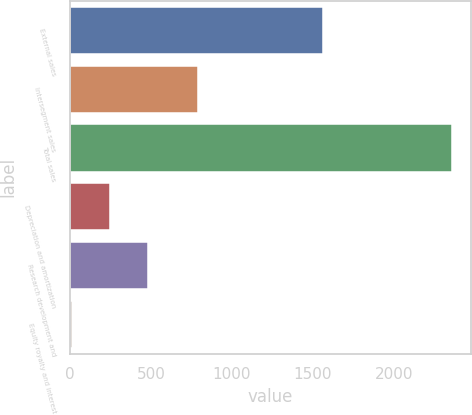Convert chart. <chart><loc_0><loc_0><loc_500><loc_500><bar_chart><fcel>External sales<fcel>Intersegment sales<fcel>Total sales<fcel>Depreciation and amortization<fcel>Research development and<fcel>Equity royalty and interest<nl><fcel>1562<fcel>793<fcel>2355<fcel>247.2<fcel>481.4<fcel>13<nl></chart> 